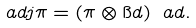Convert formula to latex. <formula><loc_0><loc_0><loc_500><loc_500>\ a d j \pi = ( \pi \otimes \i d ) \ a d .</formula> 